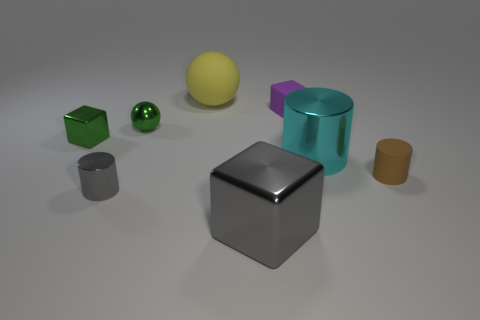Add 1 small green shiny cylinders. How many objects exist? 9 Subtract all spheres. How many objects are left? 6 Subtract all purple cubes. Subtract all tiny spheres. How many objects are left? 6 Add 6 big gray blocks. How many big gray blocks are left? 7 Add 8 tiny gray things. How many tiny gray things exist? 9 Subtract 1 gray cylinders. How many objects are left? 7 